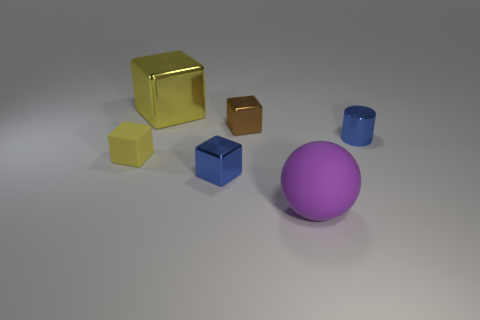Subtract all blue cubes. How many cubes are left? 3 Subtract 1 spheres. How many spheres are left? 0 Add 2 small objects. How many objects exist? 8 Subtract all yellow cubes. How many cubes are left? 2 Subtract 0 cyan cylinders. How many objects are left? 6 Subtract all spheres. How many objects are left? 5 Subtract all red balls. Subtract all brown cubes. How many balls are left? 1 Subtract all purple cylinders. How many yellow blocks are left? 2 Subtract all small cyan matte spheres. Subtract all tiny blue metallic cylinders. How many objects are left? 5 Add 4 yellow cubes. How many yellow cubes are left? 6 